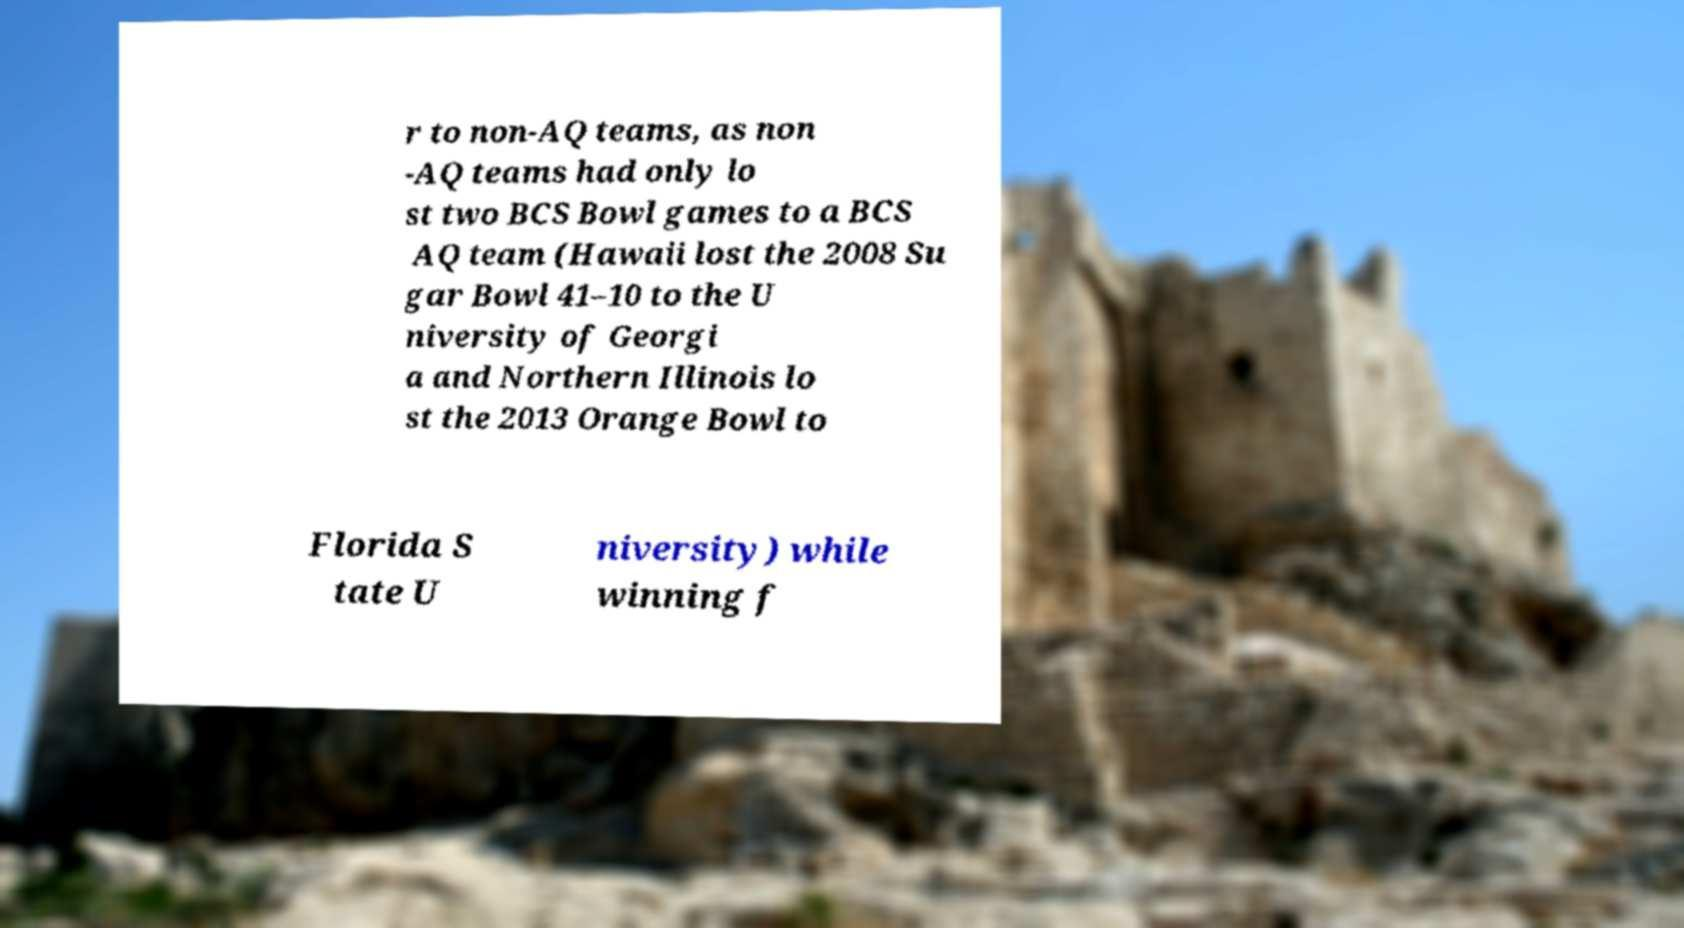I need the written content from this picture converted into text. Can you do that? r to non-AQ teams, as non -AQ teams had only lo st two BCS Bowl games to a BCS AQ team (Hawaii lost the 2008 Su gar Bowl 41–10 to the U niversity of Georgi a and Northern Illinois lo st the 2013 Orange Bowl to Florida S tate U niversity) while winning f 